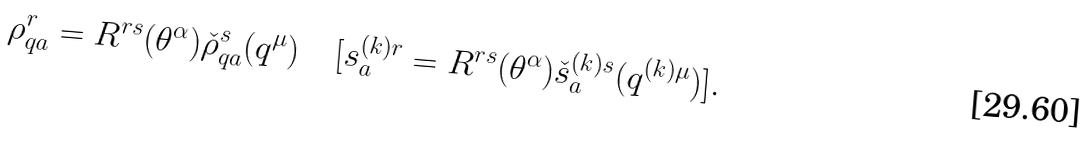Convert formula to latex. <formula><loc_0><loc_0><loc_500><loc_500>\rho ^ { r } _ { q a } = R ^ { r s } ( \theta ^ { \alpha } ) { \check { \rho } } ^ { s } _ { q a } ( q ^ { \mu } ) \quad [ s ^ { ( k ) r } _ { a } = R ^ { r s } ( \theta ^ { \alpha } ) { \check { s } } ^ { ( k ) s } _ { a } ( q ^ { ( k ) \mu } ) ] .</formula> 